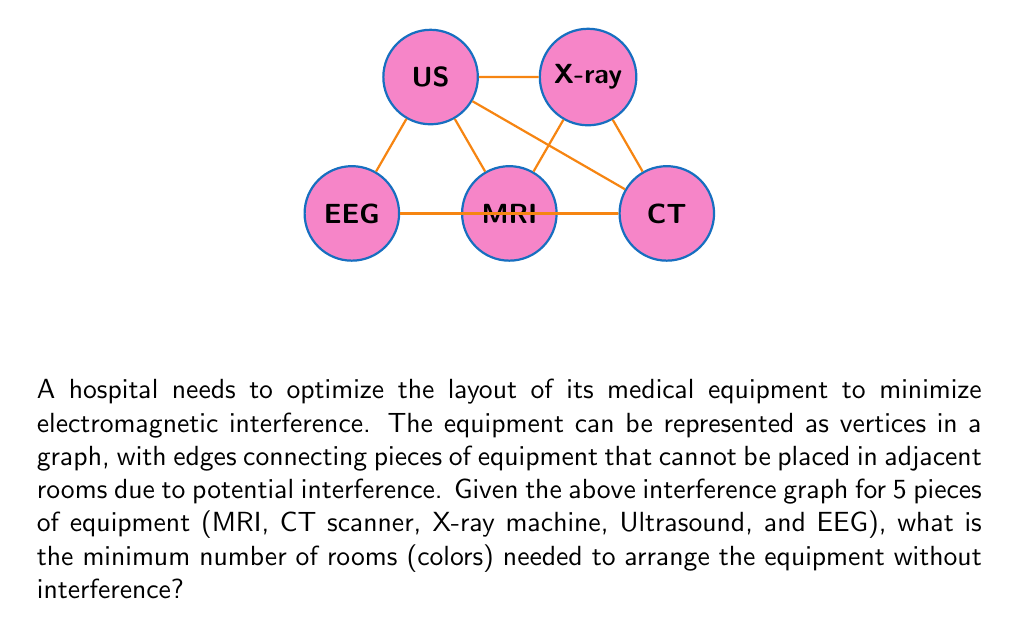Solve this math problem. To solve this problem, we'll use graph coloring techniques:

1) First, we need to understand that each color in the graph represents a separate room, and connected vertices (equipment) cannot have the same color (be in the same room).

2) We'll use the greedy coloring algorithm, which assigns the first available color to each vertex:

   a) Start with the MRI (degree 4). Assign it color 1.
   b) CT (degree 3) is connected to MRI, so assign it color 2.
   c) X-ray (degree 3) is connected to MRI and CT, so assign it color 3.
   d) Ultrasound (degree 3) is connected to MRI, CT, and X-ray, so assign it color 4.
   e) EEG (degree 2) is connected to MRI and CT, so we can assign it color 3.

3) The chromatic number $\chi(G)$ of a graph G is the minimum number of colors needed to color the graph such that no adjacent vertices have the same color.

4) In this case, we used 4 colors (rooms), and it's impossible to use fewer because we have a vertex (Ultrasound) that's connected to three others that are all connected to each other, forming a clique of size 4.

5) Therefore, the chromatic number $\chi(G) = 4$.

This means we need a minimum of 4 rooms to arrange the equipment without interference.
Answer: 4 rooms 